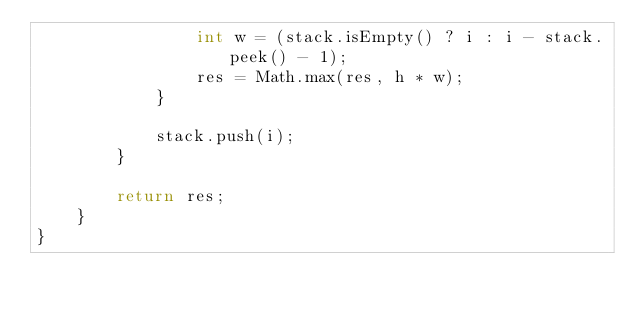Convert code to text. <code><loc_0><loc_0><loc_500><loc_500><_Java_>                int w = (stack.isEmpty() ? i : i - stack.peek() - 1);
                res = Math.max(res, h * w);
            }
            
            stack.push(i);
        }
        
        return res;
    }
}</code> 